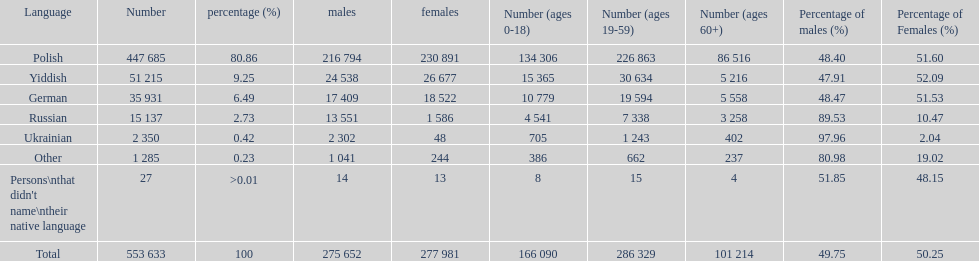Which language did only .42% of people in the imperial census of 1897 speak in the p&#322;ock governorate? Ukrainian. Would you mind parsing the complete table? {'header': ['Language', 'Number', 'percentage (%)', 'males', 'females', 'Number (ages 0-18)', 'Number (ages 19-59)', 'Number (ages 60+)', 'Percentage of males (%)', 'Percentage of Females (%)'], 'rows': [['Polish', '447 685', '80.86', '216 794', '230 891', '134 306', '226 863', '86 516', '48.40', '51.60'], ['Yiddish', '51 215', '9.25', '24 538', '26 677', '15 365', '30 634', '5 216', '47.91', '52.09'], ['German', '35 931', '6.49', '17 409', '18 522', '10 779', '19 594', '5 558', '48.47', '51.53'], ['Russian', '15 137', '2.73', '13 551', '1 586', '4 541', '7 338', '3 258', '89.53', '10.47'], ['Ukrainian', '2 350', '0.42', '2 302', '48', '705', '1 243', '402', '97.96', '2.04'], ['Other', '1 285', '0.23', '1 041', '244', '386', '662', '237', '80.98', '19.02'], ["Persons\\nthat didn't name\\ntheir native language", '27', '>0.01', '14', '13', '8', '15', '4', '51.85', '48.15'], ['Total', '553 633', '100', '275 652', '277 981', '166 090', '286 329', '101 214', '49.75', '50.25']]} 